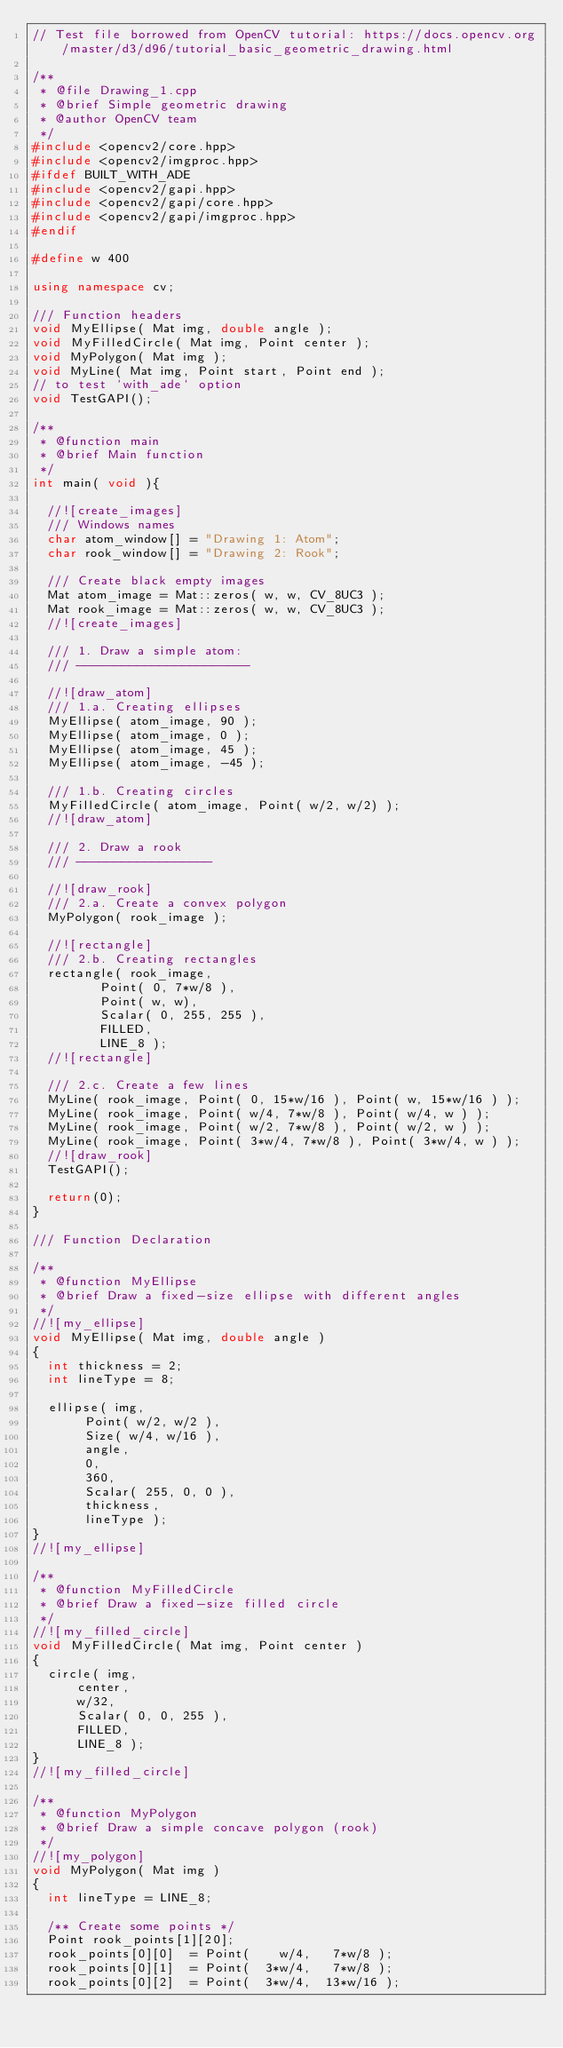Convert code to text. <code><loc_0><loc_0><loc_500><loc_500><_C++_>// Test file borrowed from OpenCV tutorial: https://docs.opencv.org/master/d3/d96/tutorial_basic_geometric_drawing.html

/**
 * @file Drawing_1.cpp
 * @brief Simple geometric drawing
 * @author OpenCV team
 */
#include <opencv2/core.hpp>
#include <opencv2/imgproc.hpp>
#ifdef BUILT_WITH_ADE
#include <opencv2/gapi.hpp>
#include <opencv2/gapi/core.hpp>
#include <opencv2/gapi/imgproc.hpp>
#endif

#define w 400

using namespace cv;

/// Function headers
void MyEllipse( Mat img, double angle );
void MyFilledCircle( Mat img, Point center );
void MyPolygon( Mat img );
void MyLine( Mat img, Point start, Point end );
// to test `with_ade` option
void TestGAPI();

/**
 * @function main
 * @brief Main function
 */
int main( void ){

  //![create_images]
  /// Windows names
  char atom_window[] = "Drawing 1: Atom";
  char rook_window[] = "Drawing 2: Rook";

  /// Create black empty images
  Mat atom_image = Mat::zeros( w, w, CV_8UC3 );
  Mat rook_image = Mat::zeros( w, w, CV_8UC3 );
  //![create_images]

  /// 1. Draw a simple atom:
  /// -----------------------

  //![draw_atom]
  /// 1.a. Creating ellipses
  MyEllipse( atom_image, 90 );
  MyEllipse( atom_image, 0 );
  MyEllipse( atom_image, 45 );
  MyEllipse( atom_image, -45 );

  /// 1.b. Creating circles
  MyFilledCircle( atom_image, Point( w/2, w/2) );
  //![draw_atom]

  /// 2. Draw a rook
  /// ------------------

  //![draw_rook]
  /// 2.a. Create a convex polygon
  MyPolygon( rook_image );

  //![rectangle]
  /// 2.b. Creating rectangles
  rectangle( rook_image,
         Point( 0, 7*w/8 ),
         Point( w, w),
         Scalar( 0, 255, 255 ),
         FILLED,
         LINE_8 );
  //![rectangle]

  /// 2.c. Create a few lines
  MyLine( rook_image, Point( 0, 15*w/16 ), Point( w, 15*w/16 ) );
  MyLine( rook_image, Point( w/4, 7*w/8 ), Point( w/4, w ) );
  MyLine( rook_image, Point( w/2, 7*w/8 ), Point( w/2, w ) );
  MyLine( rook_image, Point( 3*w/4, 7*w/8 ), Point( 3*w/4, w ) );
  //![draw_rook]
  TestGAPI();

  return(0);
}

/// Function Declaration

/**
 * @function MyEllipse
 * @brief Draw a fixed-size ellipse with different angles
 */
//![my_ellipse]
void MyEllipse( Mat img, double angle )
{
  int thickness = 2;
  int lineType = 8;

  ellipse( img,
       Point( w/2, w/2 ),
       Size( w/4, w/16 ),
       angle,
       0,
       360,
       Scalar( 255, 0, 0 ),
       thickness,
       lineType );
}
//![my_ellipse]

/**
 * @function MyFilledCircle
 * @brief Draw a fixed-size filled circle
 */
//![my_filled_circle]
void MyFilledCircle( Mat img, Point center )
{
  circle( img,
      center,
      w/32,
      Scalar( 0, 0, 255 ),
      FILLED,
      LINE_8 );
}
//![my_filled_circle]

/**
 * @function MyPolygon
 * @brief Draw a simple concave polygon (rook)
 */
//![my_polygon]
void MyPolygon( Mat img )
{
  int lineType = LINE_8;

  /** Create some points */
  Point rook_points[1][20];
  rook_points[0][0]  = Point(    w/4,   7*w/8 );
  rook_points[0][1]  = Point(  3*w/4,   7*w/8 );
  rook_points[0][2]  = Point(  3*w/4,  13*w/16 );</code> 